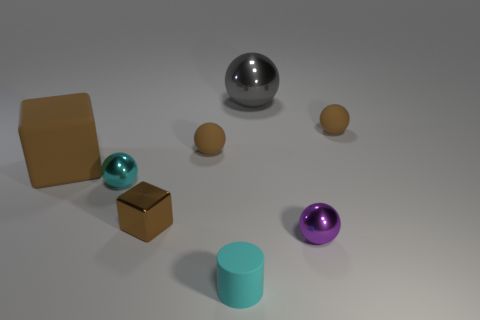Subtract all gray balls. How many balls are left? 4 Subtract all gray cylinders. How many brown spheres are left? 2 Add 1 gray metallic spheres. How many objects exist? 9 Subtract all cyan spheres. How many spheres are left? 4 Subtract all spheres. How many objects are left? 3 Subtract 1 balls. How many balls are left? 4 Subtract 0 green balls. How many objects are left? 8 Subtract all green blocks. Subtract all blue cylinders. How many blocks are left? 2 Subtract all small brown shiny things. Subtract all small brown matte balls. How many objects are left? 5 Add 5 small shiny objects. How many small shiny objects are left? 8 